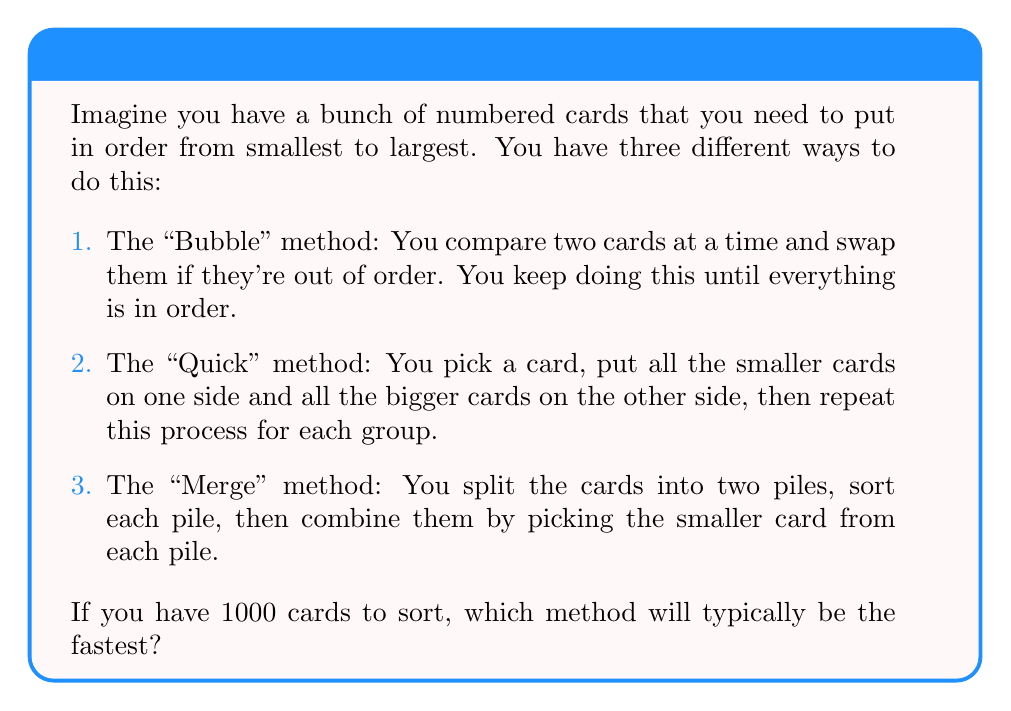Could you help me with this problem? Let's think about this step-by-step:

1. The "Bubble" method (also known as Bubble Sort):
   - This method compares adjacent elements and swaps them if they're in the wrong order.
   - It needs to go through the list many times until no more swaps are needed.
   - For 1000 cards, in the worst case, it might need to make up to 999,000 comparisons.
   - We say this method takes about $O(n^2)$ time, where $n$ is the number of cards.

2. The "Quick" method (also known as QuickSort):
   - This method picks a 'pivot' element and partitions the other elements into two sub-arrays.
   - It then recursively sorts the sub-arrays.
   - On average, it makes about $n \log n$ comparisons for $n$ elements.
   - We say this method typically takes $O(n \log n)$ time.

3. The "Merge" method (also known as Merge Sort):
   - This method divides the array into two halves, recursively sorts them, and then merges the two sorted halves.
   - It always makes about $n \log n$ comparisons for $n$ elements.
   - We also say this method takes $O(n \log n)$ time.

For 1000 cards:
- Bubble method: up to 999,000 comparisons in the worst case.
- Quick method: about 10,000 comparisons on average.
- Merge method: about 10,000 comparisons.

Both the Quick and Merge methods are much faster than the Bubble method for large numbers of cards. Between Quick and Merge, Quick is often slightly faster in practice, even though they have the same time complexity.
Answer: The "Quick" method (QuickSort) will typically be the fastest for sorting 1000 cards. 